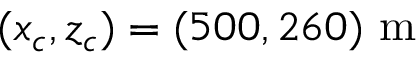<formula> <loc_0><loc_0><loc_500><loc_500>( x _ { c } , z _ { c } ) = ( 5 0 0 , 2 6 0 ) m</formula> 